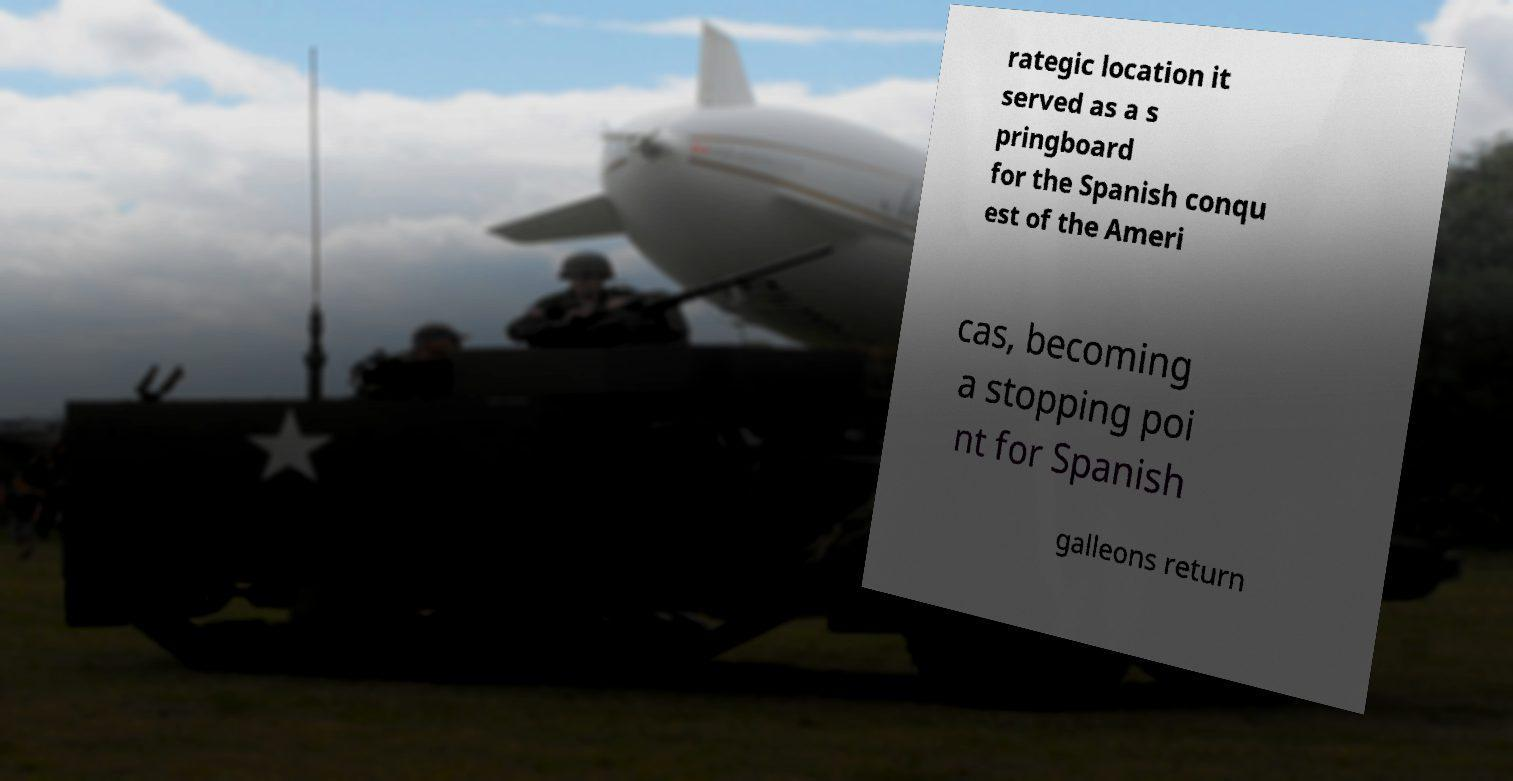Can you accurately transcribe the text from the provided image for me? rategic location it served as a s pringboard for the Spanish conqu est of the Ameri cas, becoming a stopping poi nt for Spanish galleons return 